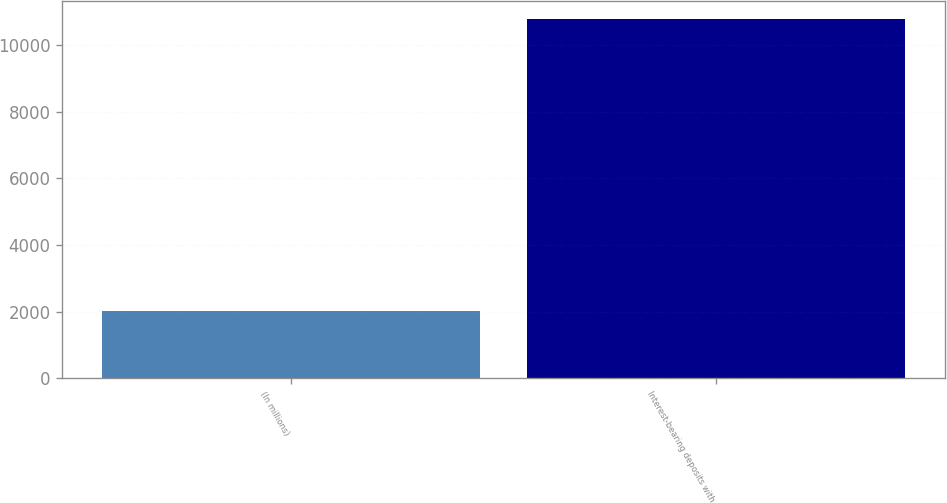Convert chart. <chart><loc_0><loc_0><loc_500><loc_500><bar_chart><fcel>(In millions)<fcel>Interest-bearing deposits with<nl><fcel>2011<fcel>10772<nl></chart> 